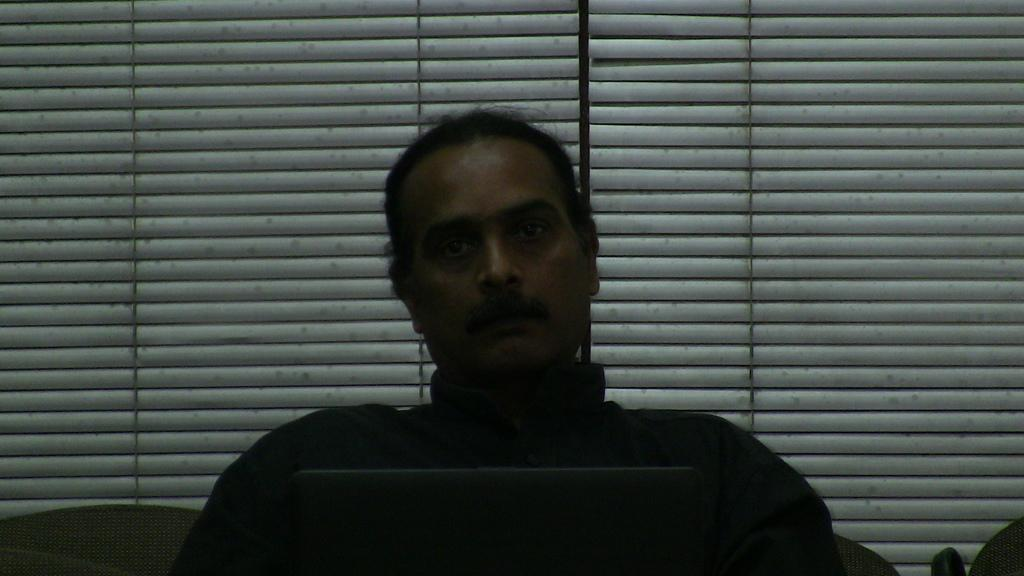Who is present in the image? There is a man in the image. What object can be seen with the man? There is a laptop in the image. What type of material is used for the curtain in the image? There is a wooden curtain visible in the image. What type of canvas is the owl painting on in the image? There is no canvas or owl present in the image. 